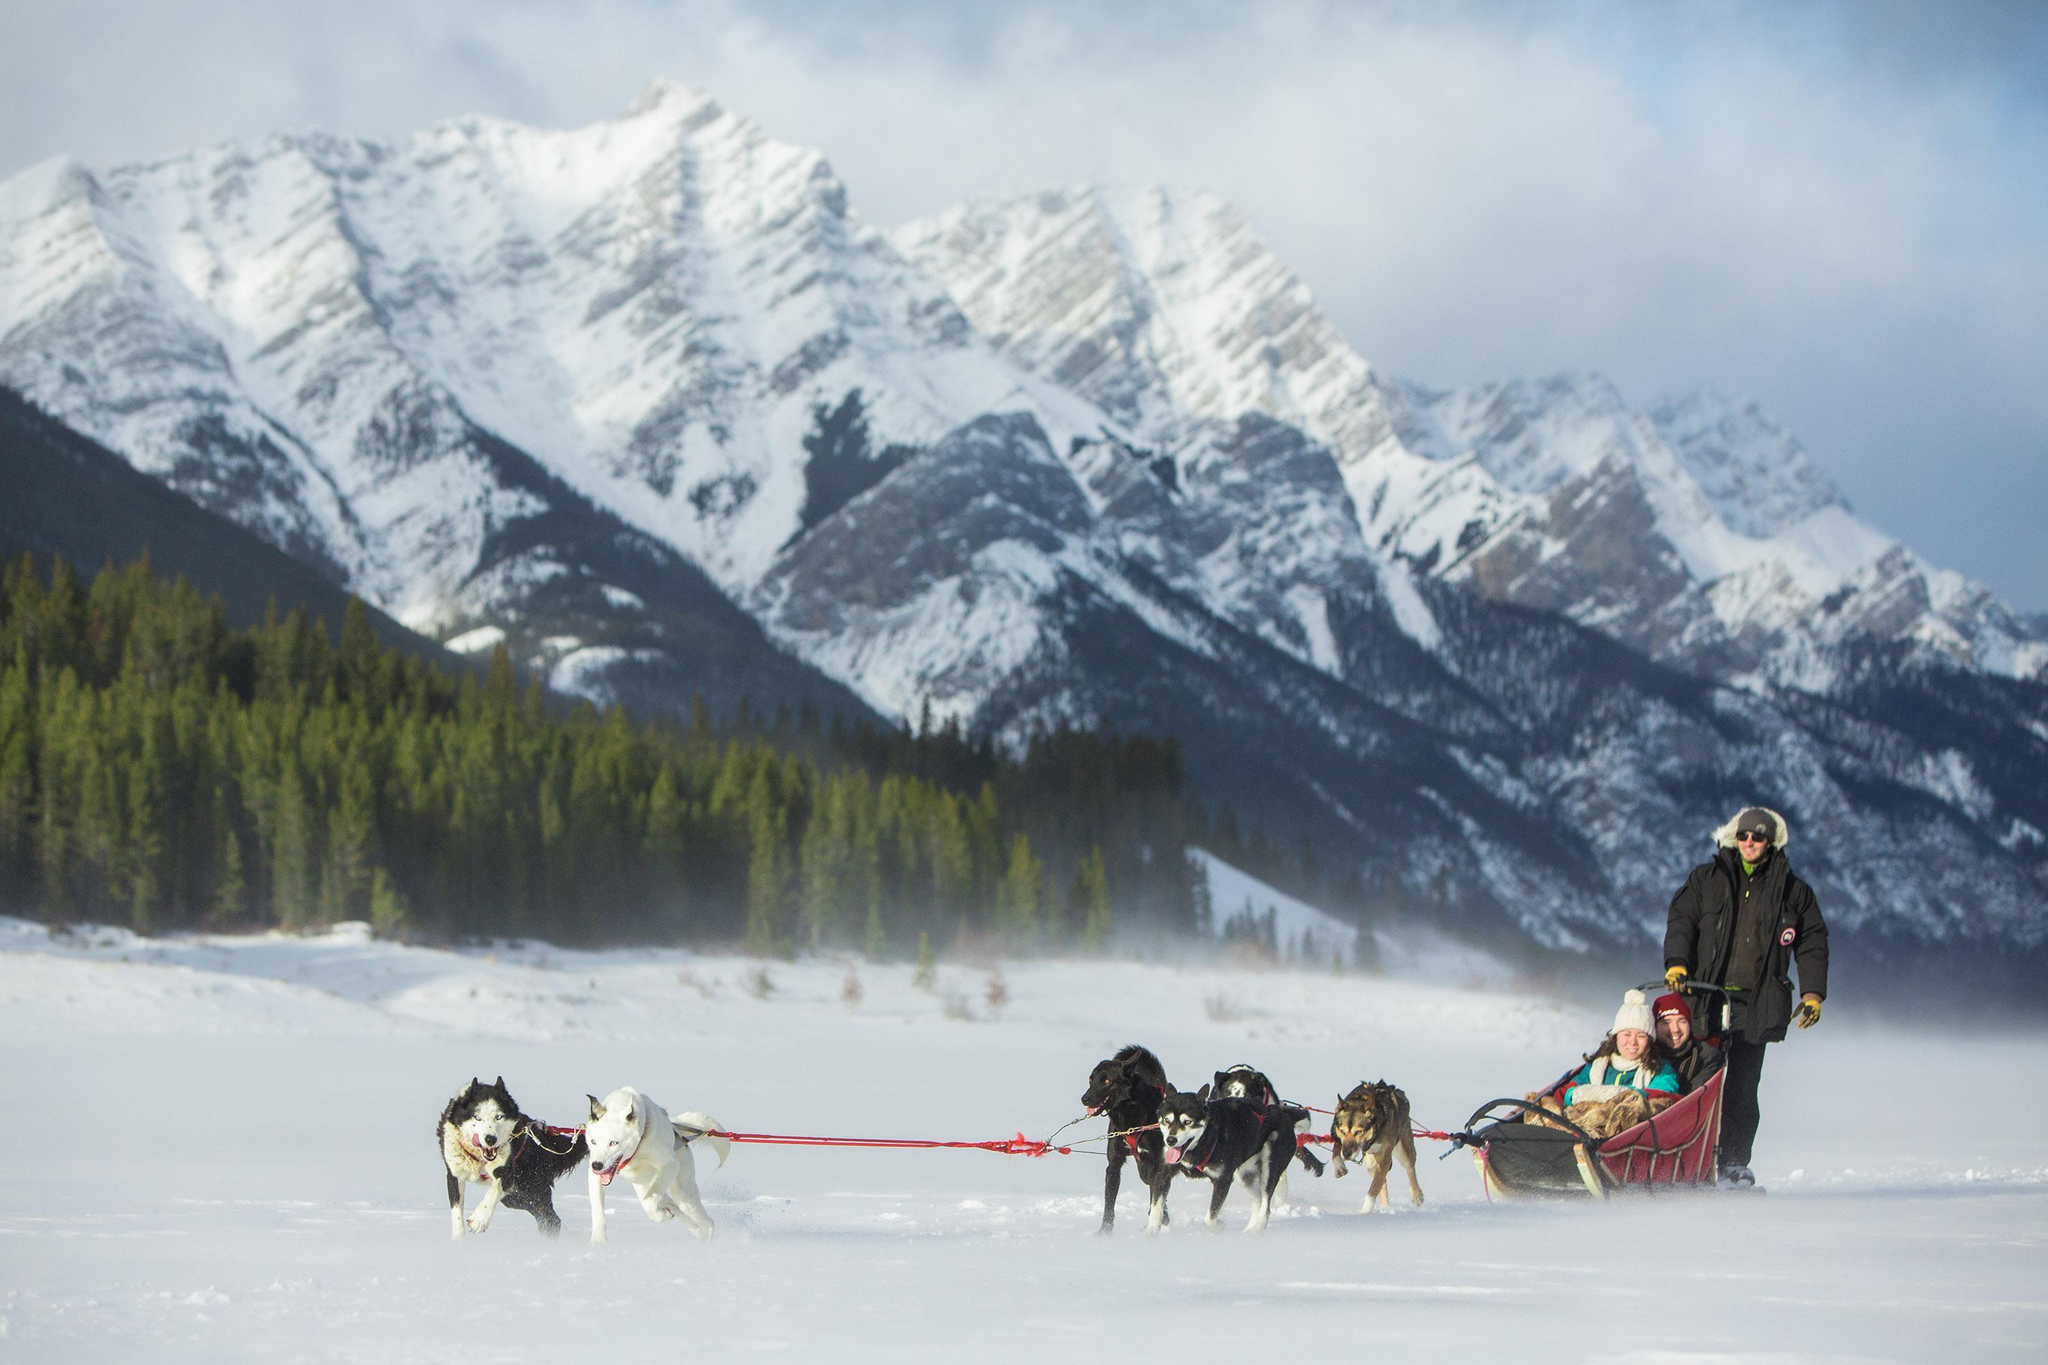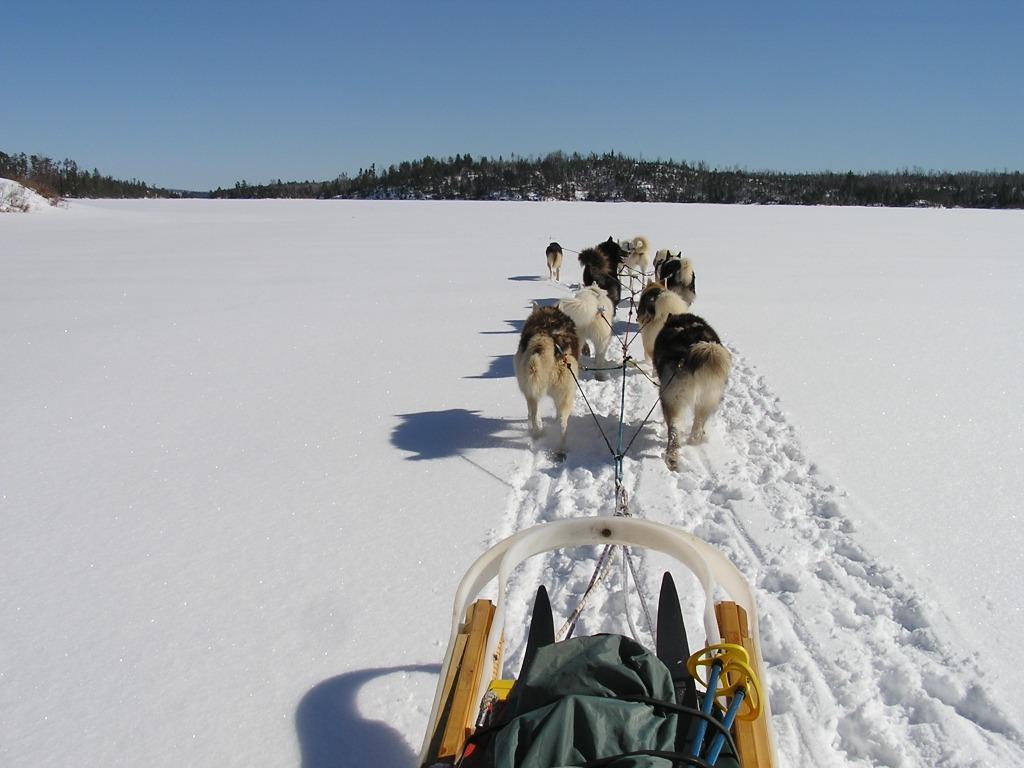The first image is the image on the left, the second image is the image on the right. Evaluate the accuracy of this statement regarding the images: "The dog team in the right image is moving away from the camera, and the dog team on the left is also moving, but not away from the camera.". Is it true? Answer yes or no. Yes. The first image is the image on the left, the second image is the image on the right. Evaluate the accuracy of this statement regarding the images: "All the dogs are moving forward.". Is it true? Answer yes or no. Yes. 